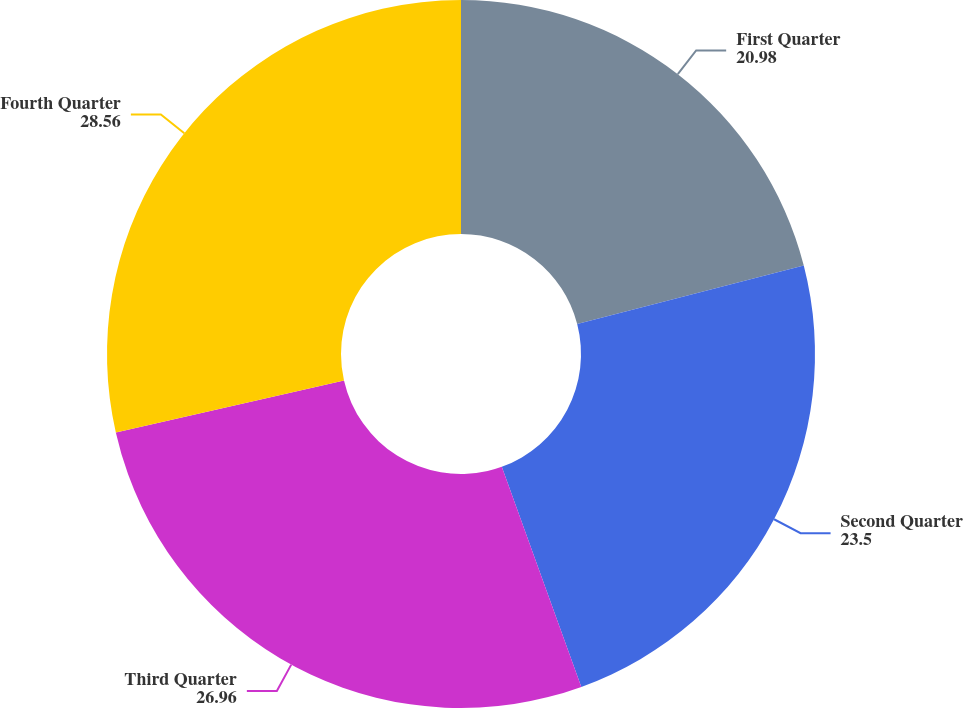Convert chart to OTSL. <chart><loc_0><loc_0><loc_500><loc_500><pie_chart><fcel>First Quarter<fcel>Second Quarter<fcel>Third Quarter<fcel>Fourth Quarter<nl><fcel>20.98%<fcel>23.5%<fcel>26.96%<fcel>28.56%<nl></chart> 